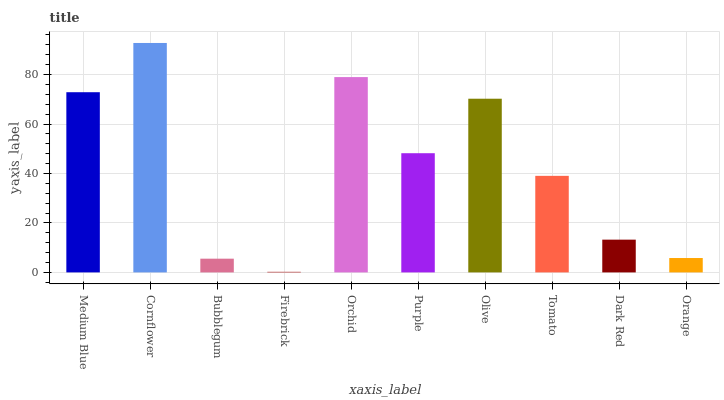Is Bubblegum the minimum?
Answer yes or no. No. Is Bubblegum the maximum?
Answer yes or no. No. Is Cornflower greater than Bubblegum?
Answer yes or no. Yes. Is Bubblegum less than Cornflower?
Answer yes or no. Yes. Is Bubblegum greater than Cornflower?
Answer yes or no. No. Is Cornflower less than Bubblegum?
Answer yes or no. No. Is Purple the high median?
Answer yes or no. Yes. Is Tomato the low median?
Answer yes or no. Yes. Is Firebrick the high median?
Answer yes or no. No. Is Medium Blue the low median?
Answer yes or no. No. 